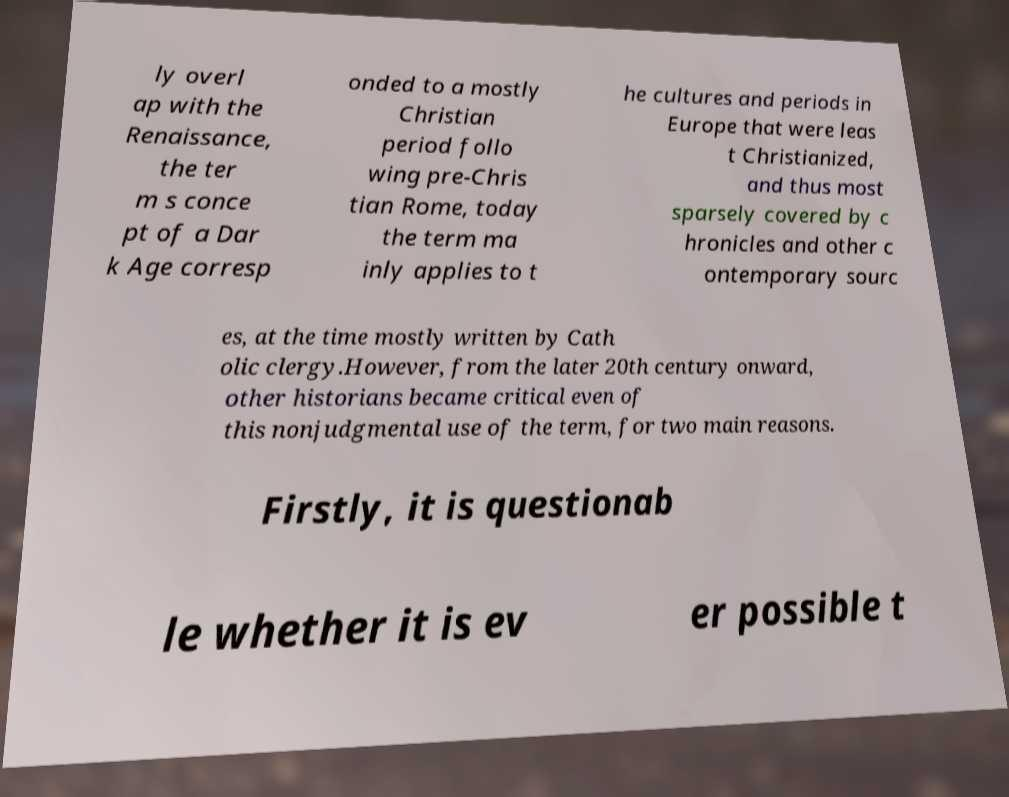What messages or text are displayed in this image? I need them in a readable, typed format. ly overl ap with the Renaissance, the ter m s conce pt of a Dar k Age corresp onded to a mostly Christian period follo wing pre-Chris tian Rome, today the term ma inly applies to t he cultures and periods in Europe that were leas t Christianized, and thus most sparsely covered by c hronicles and other c ontemporary sourc es, at the time mostly written by Cath olic clergy.However, from the later 20th century onward, other historians became critical even of this nonjudgmental use of the term, for two main reasons. Firstly, it is questionab le whether it is ev er possible t 